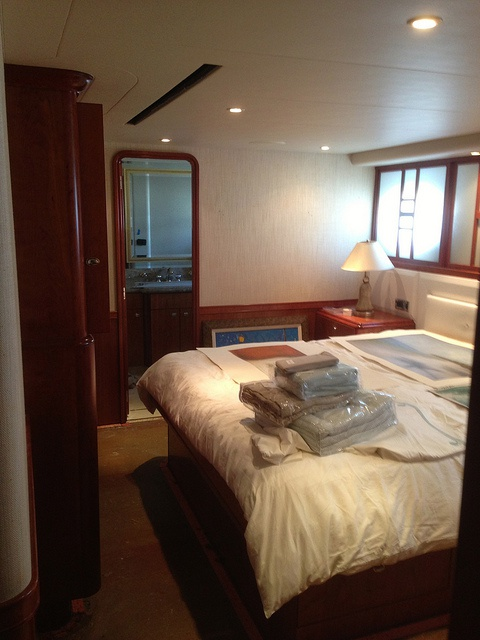Describe the objects in this image and their specific colors. I can see bed in gray and tan tones and sink in gray, blue, and black tones in this image. 